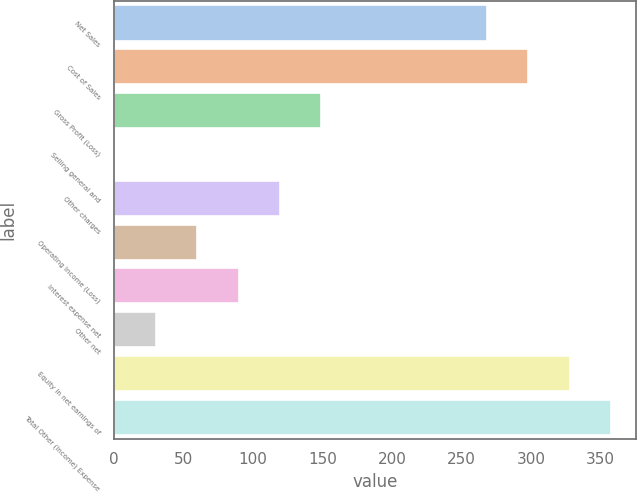Convert chart to OTSL. <chart><loc_0><loc_0><loc_500><loc_500><bar_chart><fcel>Net Sales<fcel>Cost of Sales<fcel>Gross Profit (Loss)<fcel>Selling general and<fcel>Other charges<fcel>Operating Income (Loss)<fcel>Interest expense net<fcel>Other net<fcel>Equity in net earnings of<fcel>Total Other (Income) Expense<nl><fcel>268.19<fcel>297.97<fcel>149.07<fcel>0.17<fcel>119.29<fcel>59.73<fcel>89.51<fcel>29.95<fcel>327.75<fcel>357.53<nl></chart> 